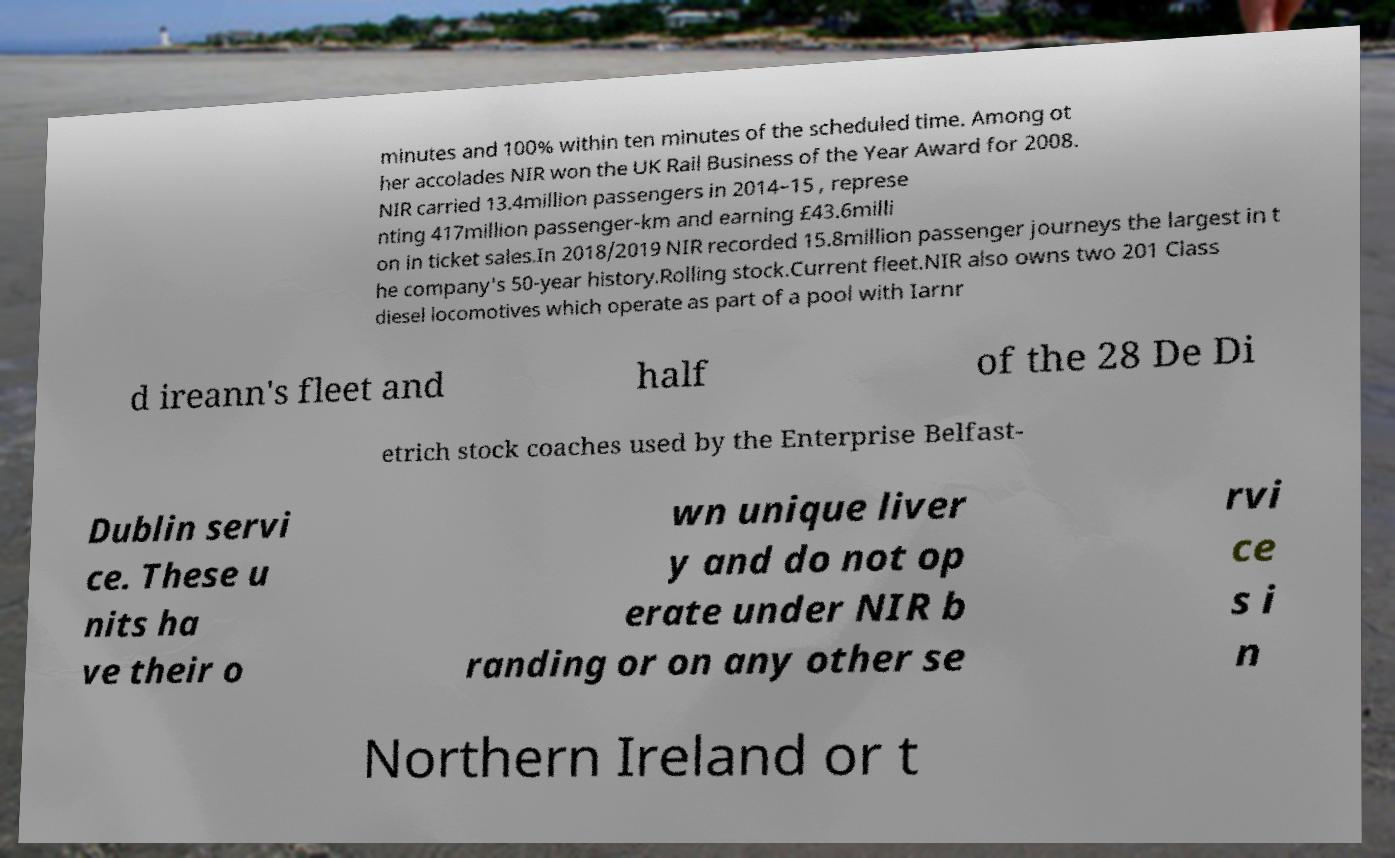For documentation purposes, I need the text within this image transcribed. Could you provide that? minutes and 100% within ten minutes of the scheduled time. Among ot her accolades NIR won the UK Rail Business of the Year Award for 2008. NIR carried 13.4million passengers in 2014–15 , represe nting 417million passenger-km and earning £43.6milli on in ticket sales.In 2018/2019 NIR recorded 15.8million passenger journeys the largest in t he company's 50-year history.Rolling stock.Current fleet.NIR also owns two 201 Class diesel locomotives which operate as part of a pool with Iarnr d ireann's fleet and half of the 28 De Di etrich stock coaches used by the Enterprise Belfast- Dublin servi ce. These u nits ha ve their o wn unique liver y and do not op erate under NIR b randing or on any other se rvi ce s i n Northern Ireland or t 